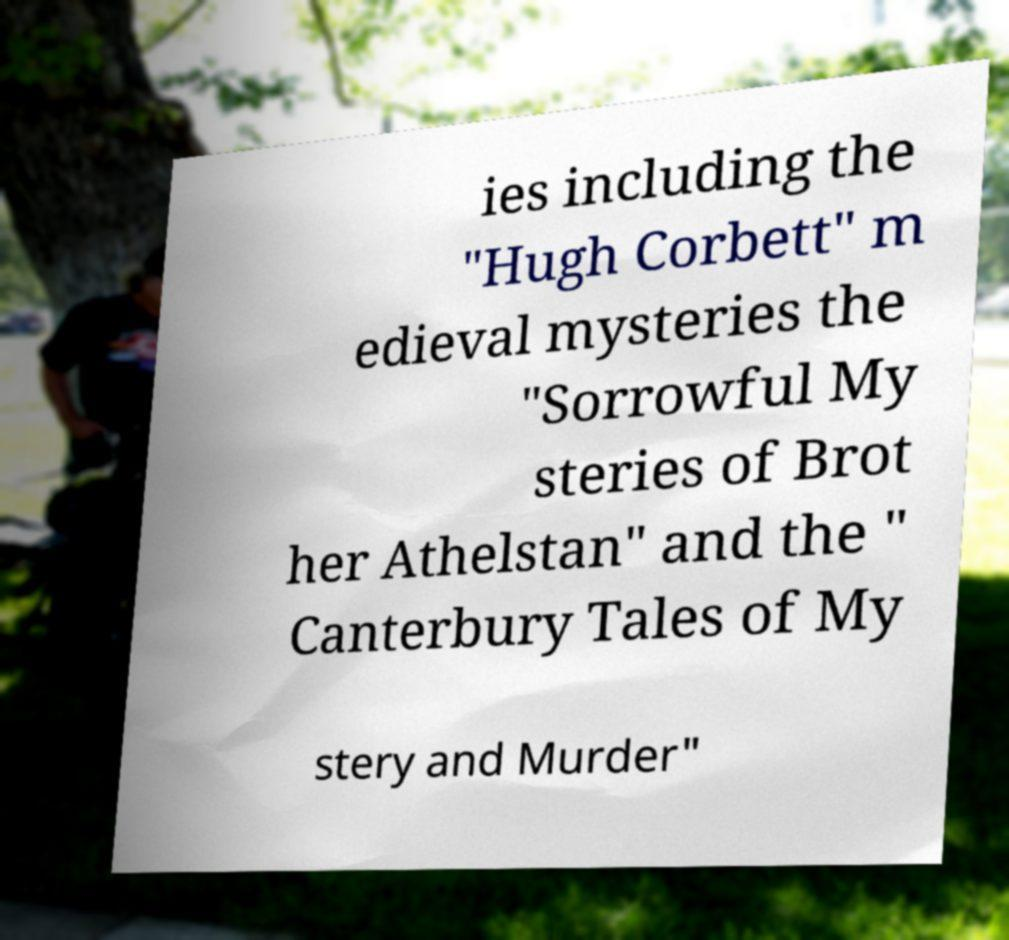What messages or text are displayed in this image? I need them in a readable, typed format. ies including the "Hugh Corbett" m edieval mysteries the "Sorrowful My steries of Brot her Athelstan" and the " Canterbury Tales of My stery and Murder" 